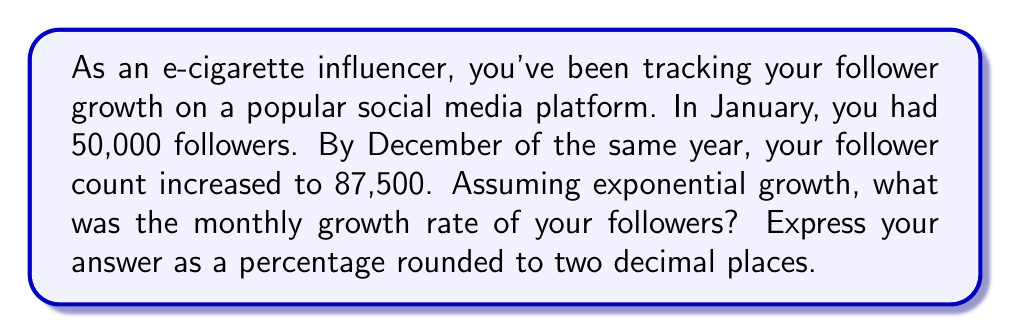Teach me how to tackle this problem. Let's approach this step-by-step:

1) We'll use the exponential growth formula:
   $$A = P(1 + r)^t$$
   Where:
   $A$ = final amount (87,500 followers)
   $P$ = initial amount (50,000 followers)
   $r$ = monthly growth rate (what we're solving for)
   $t$ = time in months (12 months from January to December)

2) Plug in the known values:
   $$87,500 = 50,000(1 + r)^{12}$$

3) Divide both sides by 50,000:
   $$1.75 = (1 + r)^{12}$$

4) Take the 12th root of both sides:
   $$\sqrt[12]{1.75} = 1 + r$$

5) Subtract 1 from both sides:
   $$\sqrt[12]{1.75} - 1 = r$$

6) Calculate:
   $$r \approx 1.0456 - 1 = 0.0456$$

7) Convert to percentage:
   $$0.0456 \times 100 = 4.56\%$$

Therefore, the monthly growth rate was approximately 4.56%.
Answer: 4.56% 